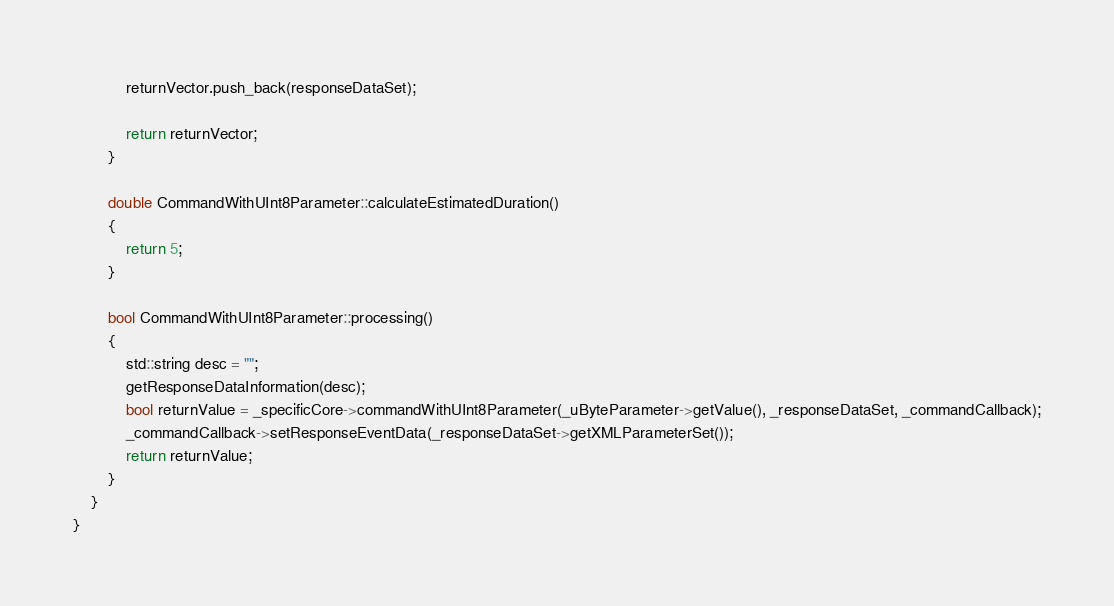<code> <loc_0><loc_0><loc_500><loc_500><_C++_>			returnVector.push_back(responseDataSet);

			return returnVector;
		}

		double CommandWithUInt8Parameter::calculateEstimatedDuration()
		{
			return 5;
		}

		bool CommandWithUInt8Parameter::processing()
		{
			std::string desc = "";
			getResponseDataInformation(desc);
			bool returnValue = _specificCore->commandWithUInt8Parameter(_uByteParameter->getValue(), _responseDataSet, _commandCallback);
			_commandCallback->setResponseEventData(_responseDataSet->getXMLParameterSet());
			return returnValue;
		}
	}
}</code> 